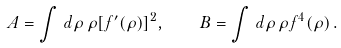<formula> <loc_0><loc_0><loc_500><loc_500>A = \int \, d \rho \, \rho [ f ^ { \prime } ( \rho ) ] ^ { 2 } , \quad B = \int \, d \rho \, \rho f ^ { 4 } ( \rho ) \, .</formula> 